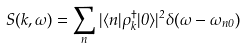Convert formula to latex. <formula><loc_0><loc_0><loc_500><loc_500>S ( { k } , \omega ) = \sum _ { n } | \langle n | \rho _ { k } ^ { \dagger } | 0 \rangle | ^ { 2 } \delta ( \omega - \omega _ { n 0 } )</formula> 